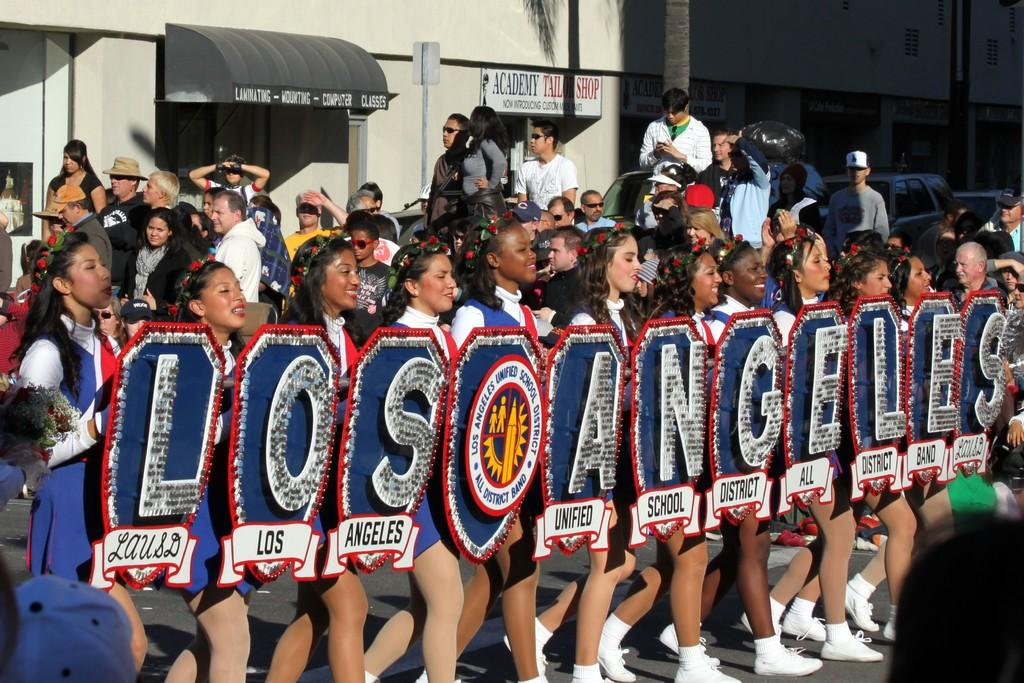<image>
Offer a succinct explanation of the picture presented. Girls walk down the street, each carrying a letter to spell out, "Los Angeles". 